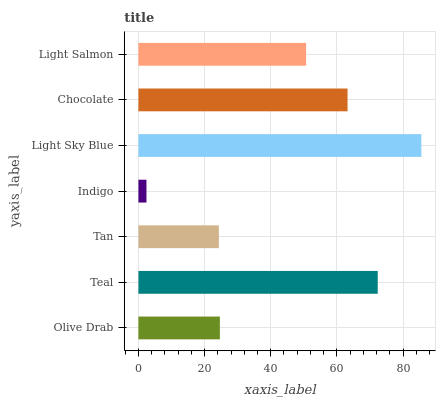Is Indigo the minimum?
Answer yes or no. Yes. Is Light Sky Blue the maximum?
Answer yes or no. Yes. Is Teal the minimum?
Answer yes or no. No. Is Teal the maximum?
Answer yes or no. No. Is Teal greater than Olive Drab?
Answer yes or no. Yes. Is Olive Drab less than Teal?
Answer yes or no. Yes. Is Olive Drab greater than Teal?
Answer yes or no. No. Is Teal less than Olive Drab?
Answer yes or no. No. Is Light Salmon the high median?
Answer yes or no. Yes. Is Light Salmon the low median?
Answer yes or no. Yes. Is Light Sky Blue the high median?
Answer yes or no. No. Is Teal the low median?
Answer yes or no. No. 